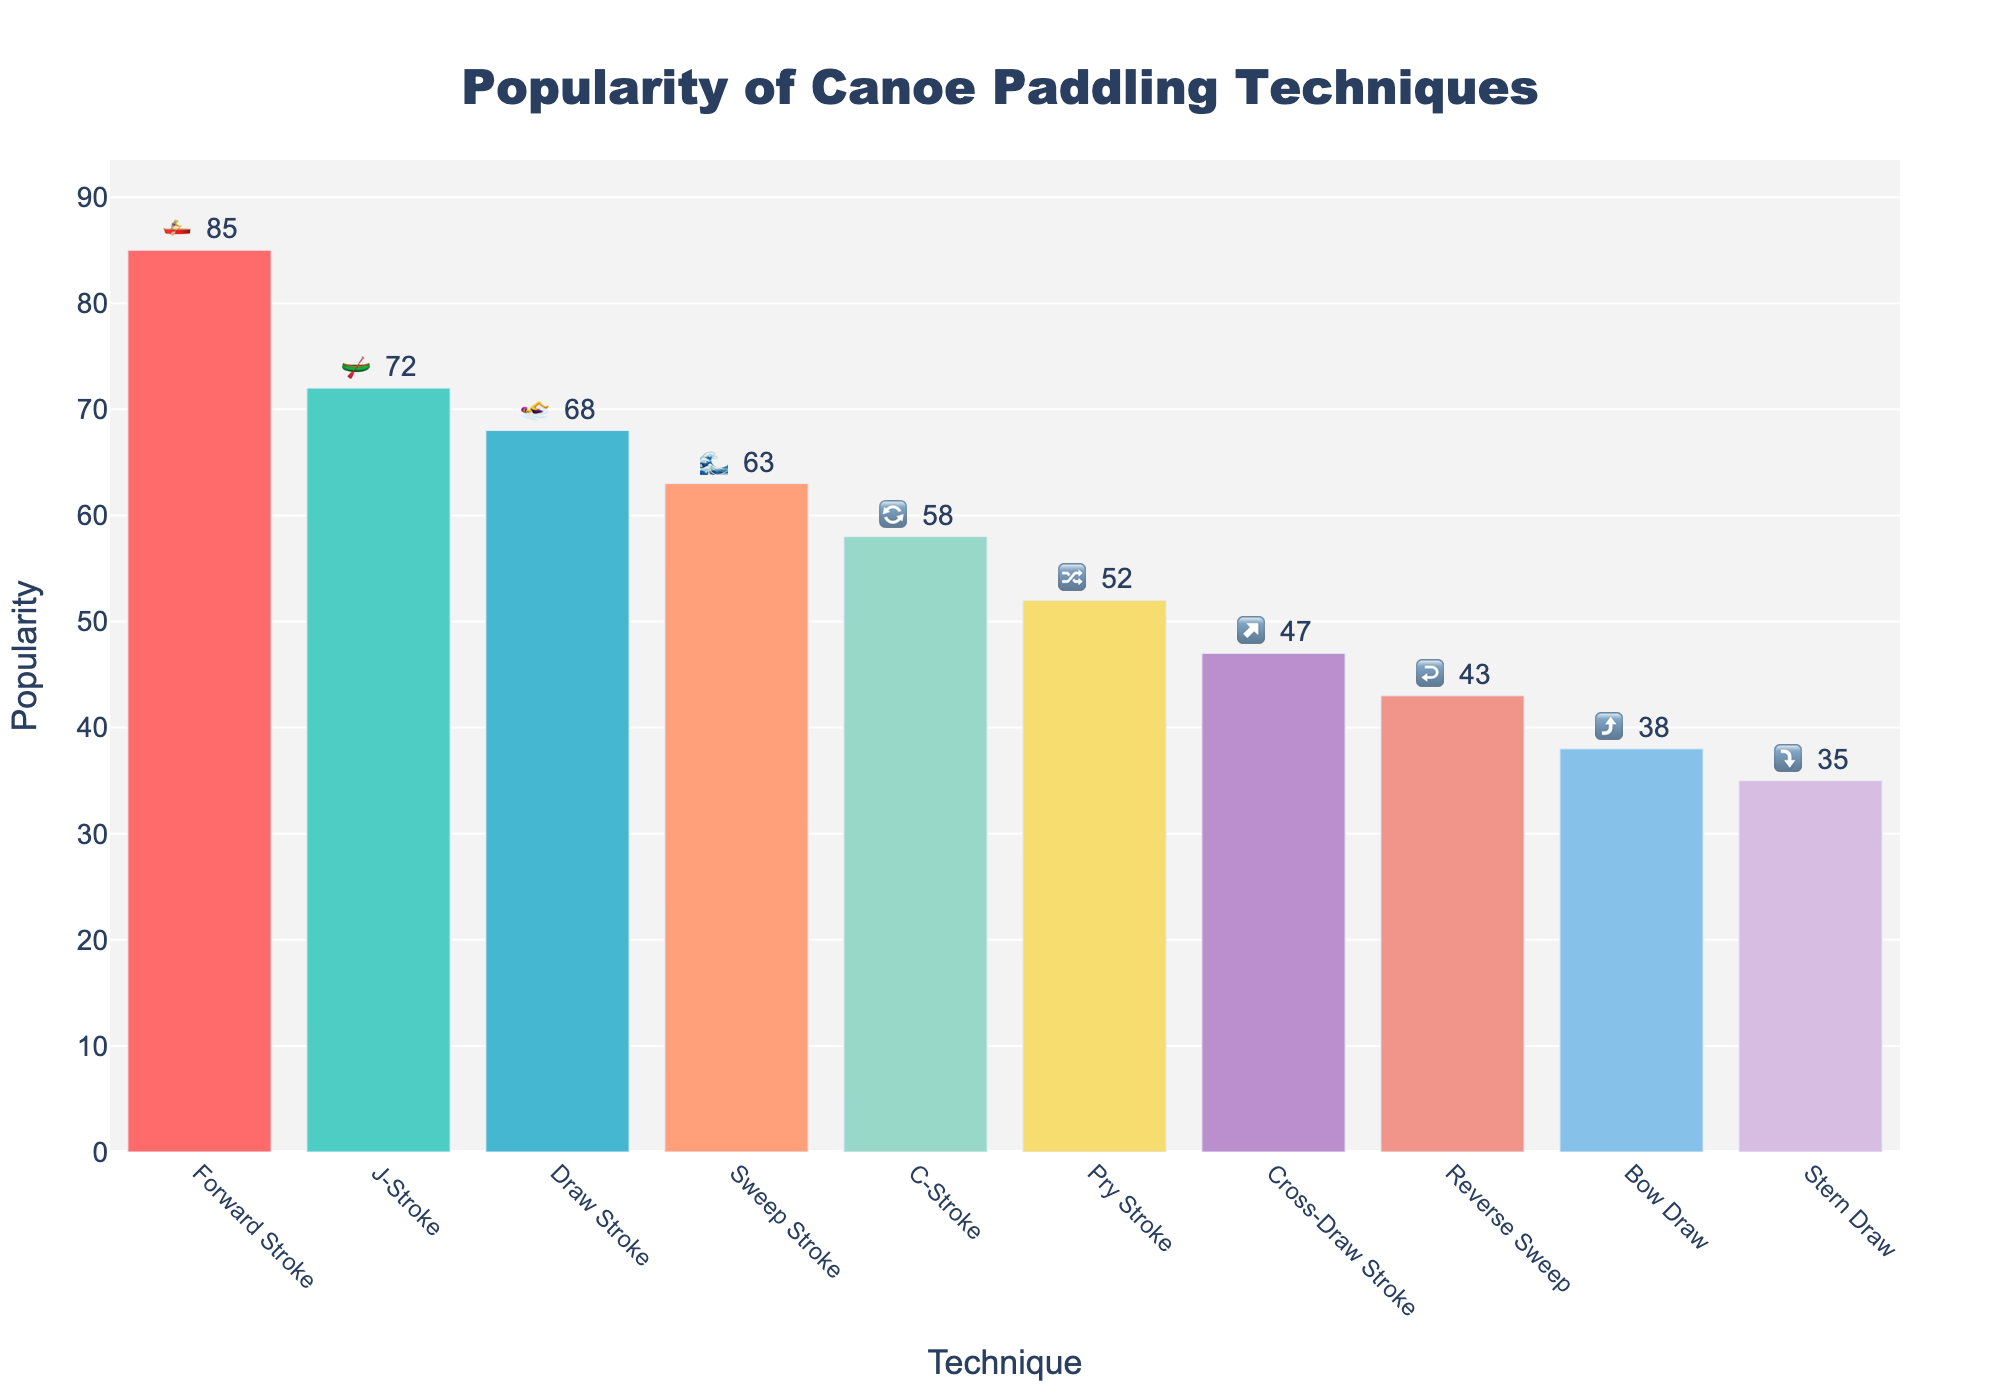What is the title of the figure? The title is usually found at the top of the figure. It provides a summary of the content.
Answer: Popularity of Canoe Paddling Techniques Which technique has the highest popularity? To find the highest popularity, look for the tallest bar in the figure.
Answer: Forward Stroke How many techniques have a popularity above 60? Count the number of bars that extend above the 60 mark on the y-axis.
Answer: Four (Forward Stroke, J-Stroke, Draw Stroke, Sweep Stroke) What is the total popularity of all techniques combined? Add the popularity values for each technique. 85 + 72 + 68 + 63 + 58 + 52 + 47 + 43 + 38 + 35 = 561.
Answer: 561 Which technique is represented by the emoji 🔀? Look for the technique with the emoji 🔀 in the text labels.
Answer: Pry Stroke By how much is the popularity of J-Stroke greater than Bow Draw? Subtract the popularity of Bow Draw from J-Stroke. 72 - 38 = 34.
Answer: 34 List the top 3 techniques in descending order of popularity. Identify and list the top three tallest bars by their popularity values.
Answer: Forward Stroke, J-Stroke, Draw Stroke What is the median value of the popularity data? List all popularity values in ascending order: 35, 38, 43, 47, 52, 58, 63, 68, 72, 85. The median is the average of the middle two values, (58 + 63) / 2 = 60.5.
Answer: 60.5 Which techniques have emojis that suggest directional motion (e.g., arrows)? Look for techniques with emojis depicting directions, such as arrows or curves.
Answer: Cross-Draw Stroke (↗️), Reverse Sweep (↩️), Bow Draw (⤴️), Stern Draw (⤵️) What is the difference in popularity between the Forward Stroke and the Sweep Stroke? Subtract the popularity of Sweep Stroke from Forward Stroke. 85 - 63 = 22.
Answer: 22 